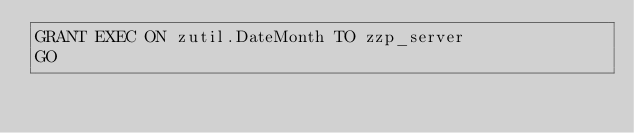Convert code to text. <code><loc_0><loc_0><loc_500><loc_500><_SQL_>GRANT EXEC ON zutil.DateMonth TO zzp_server
GO
</code> 